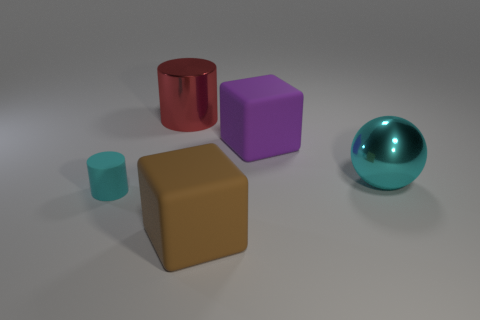Add 1 big purple blocks. How many objects exist? 6 Subtract all cylinders. How many objects are left? 3 Subtract all small purple matte blocks. Subtract all cyan metal spheres. How many objects are left? 4 Add 2 large purple objects. How many large purple objects are left? 3 Add 5 large metallic cylinders. How many large metallic cylinders exist? 6 Subtract 0 purple cylinders. How many objects are left? 5 